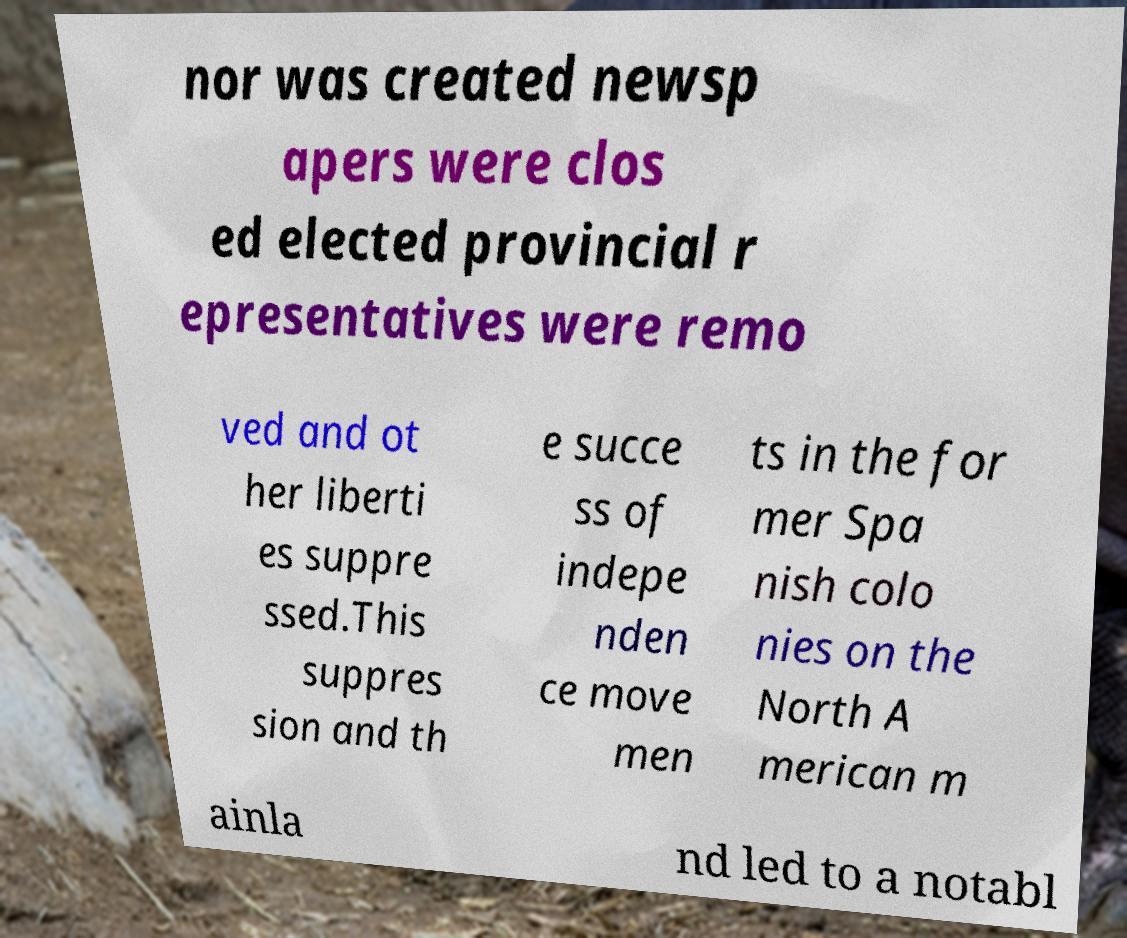There's text embedded in this image that I need extracted. Can you transcribe it verbatim? nor was created newsp apers were clos ed elected provincial r epresentatives were remo ved and ot her liberti es suppre ssed.This suppres sion and th e succe ss of indepe nden ce move men ts in the for mer Spa nish colo nies on the North A merican m ainla nd led to a notabl 